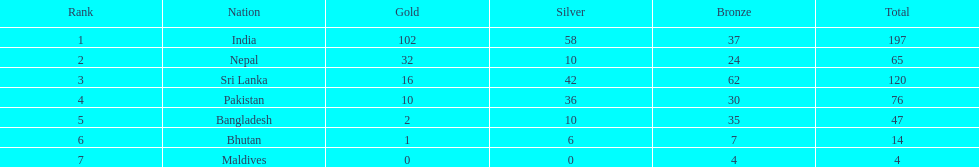What is the number of countries with a gold medal count greater than 10? 3. 